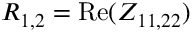Convert formula to latex. <formula><loc_0><loc_0><loc_500><loc_500>R _ { 1 , 2 } = R e ( Z _ { 1 1 , 2 2 } )</formula> 